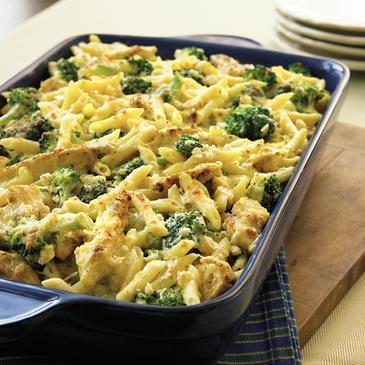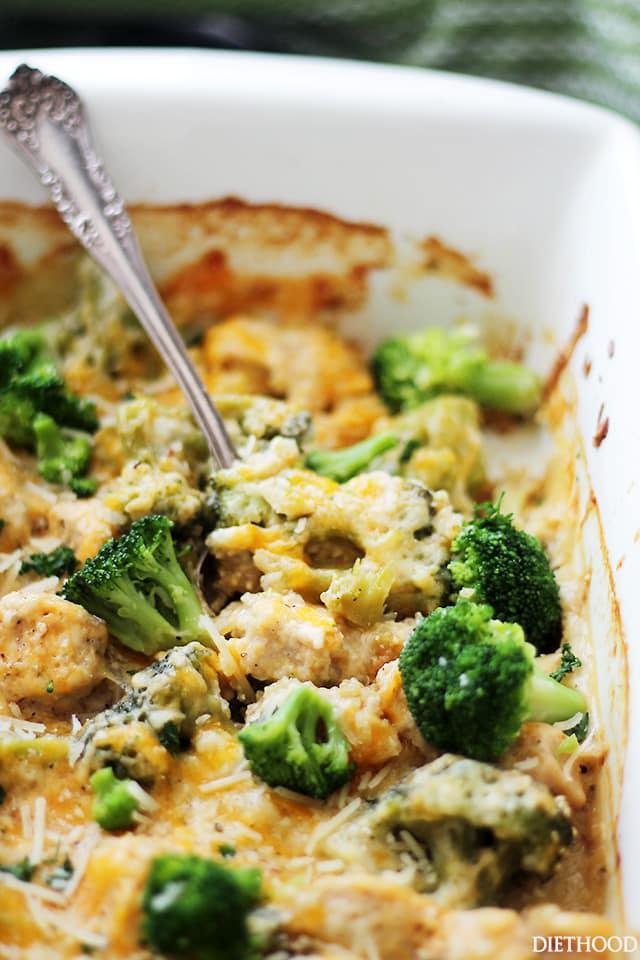The first image is the image on the left, the second image is the image on the right. Analyze the images presented: Is the assertion "There is a serving utensil in the dish on the right." valid? Answer yes or no. Yes. The first image is the image on the left, the second image is the image on the right. Given the left and right images, does the statement "A metalic spoon is in one of the food." hold true? Answer yes or no. Yes. 